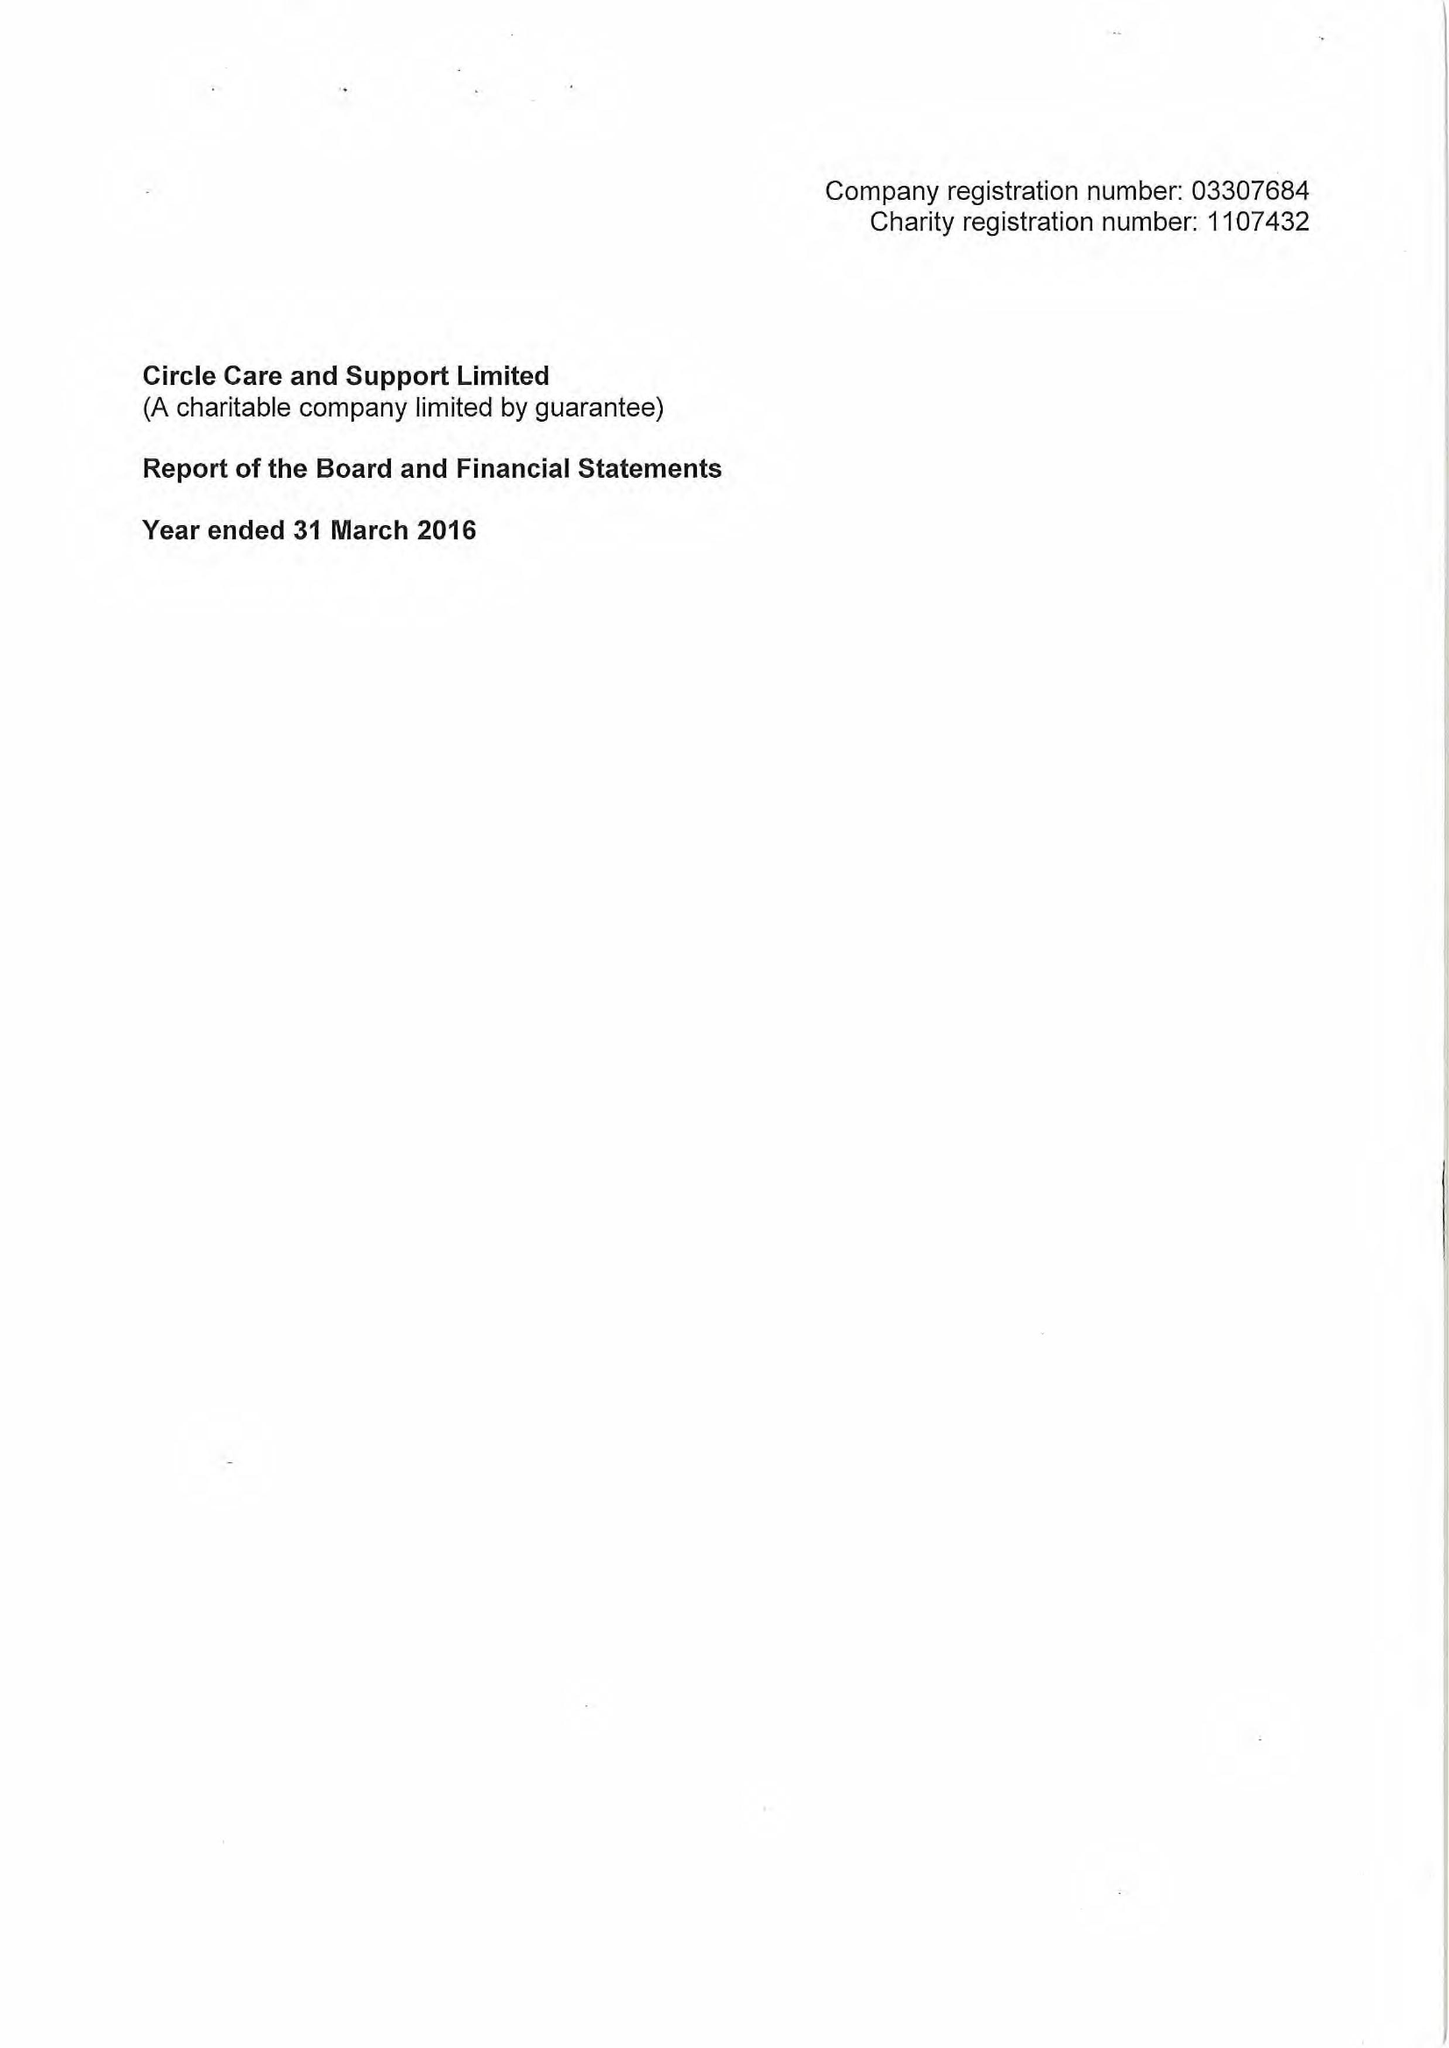What is the value for the address__post_town?
Answer the question using a single word or phrase. LONDON 